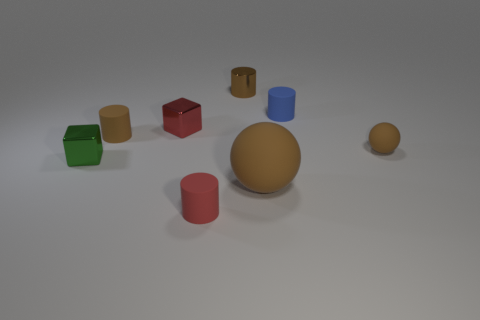Subtract all brown spheres. How many brown cylinders are left? 2 Subtract all blue matte cylinders. How many cylinders are left? 3 Subtract all blue cylinders. How many cylinders are left? 3 Subtract all cyan cylinders. Subtract all brown blocks. How many cylinders are left? 4 Add 1 large blue spheres. How many objects exist? 9 Subtract all blocks. How many objects are left? 6 Subtract all gray metallic spheres. Subtract all brown matte cylinders. How many objects are left? 7 Add 3 small blue cylinders. How many small blue cylinders are left? 4 Add 5 large yellow cylinders. How many large yellow cylinders exist? 5 Subtract 0 gray cylinders. How many objects are left? 8 